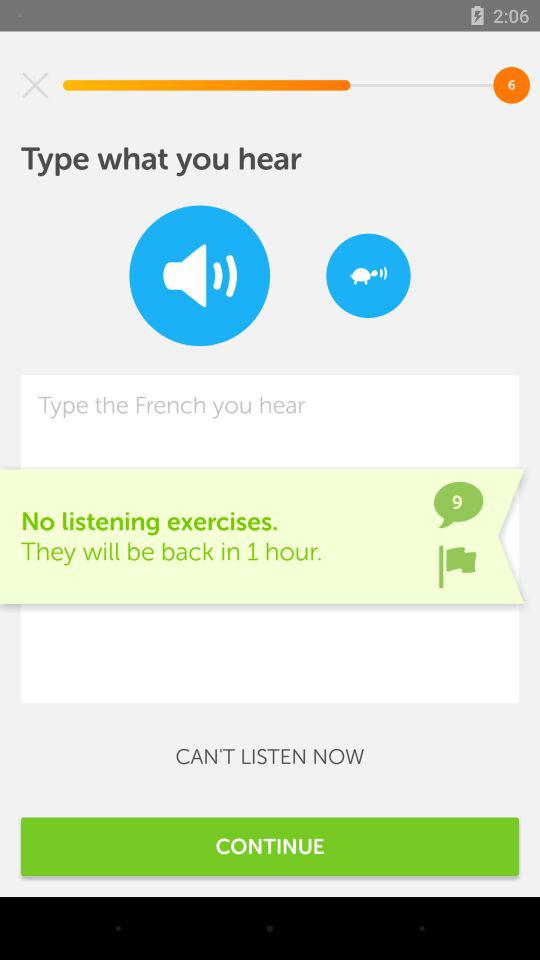How many suggestions are there? There are 9 suggestions. 